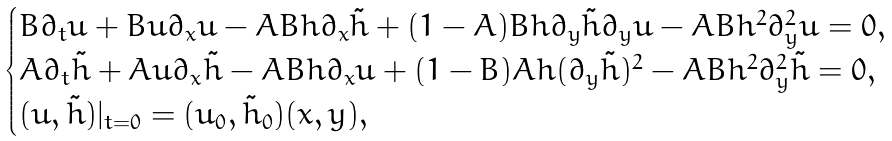Convert formula to latex. <formula><loc_0><loc_0><loc_500><loc_500>\begin{cases} B \partial _ { t } u + B u \partial _ { x } u - A B h \partial _ { x } \tilde { h } + ( 1 - A ) B h \partial _ { y } \tilde { h } \partial _ { y } u - A B h ^ { 2 } \partial _ { y } ^ { 2 } u = 0 , \\ A \partial _ { t } \tilde { h } + A u \partial _ { x } \tilde { h } - A B h \partial _ { x } u + ( 1 - B ) A h ( \partial _ { y } \tilde { h } ) ^ { 2 } - A B h ^ { 2 } \partial _ { y } ^ { 2 } \tilde { h } = 0 , \\ ( u , \tilde { h } ) | _ { t = 0 } = ( u _ { 0 } , \tilde { h } _ { 0 } ) ( x , y ) , \end{cases}</formula> 